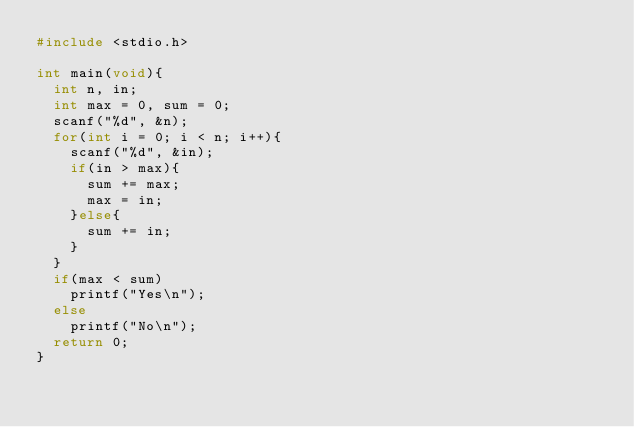<code> <loc_0><loc_0><loc_500><loc_500><_C_>#include <stdio.h>

int main(void){
	int n, in;
	int max = 0, sum = 0;
	scanf("%d", &n);
	for(int i = 0; i < n; i++){
		scanf("%d", &in);
		if(in > max){
			sum += max;
			max = in;
		}else{
			sum += in;
		}
	}
	if(max < sum)
		printf("Yes\n");
	else
		printf("No\n");
	return 0;
}
</code> 